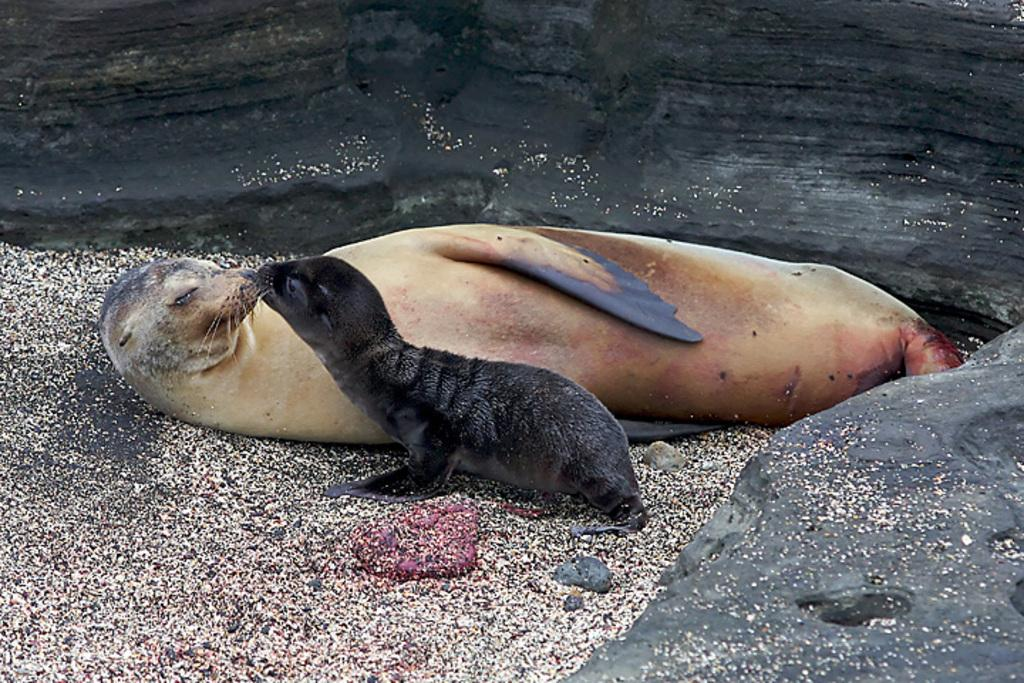What animals can be seen in the image? There are two seals in the image. Where are the seals located in the image? The seals are laying on the side of the beach. What other objects or features can be seen in the image? There is a rock on the right side of the image and a huge rock in the back of the image. What songs are the seals singing in the image? The seals are not singing songs in the image; they are laying on the beach. Is there any visible wound on the seals in the image? There is no mention of any wound on the seals in the provided facts, so we cannot determine if they have any wounds. 